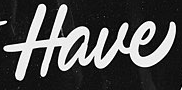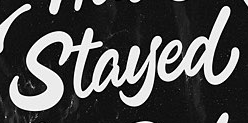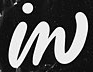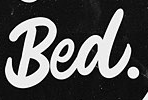Transcribe the words shown in these images in order, separated by a semicolon. Have; Stayed; in; Bed. 